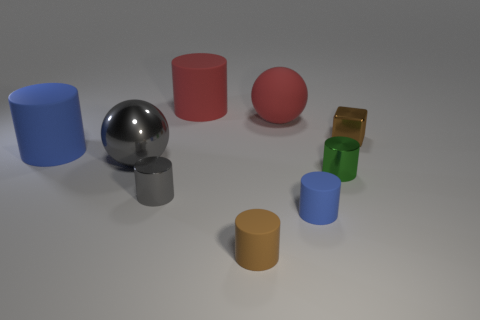There is a tiny cylinder in front of the blue thing that is right of the rubber sphere; what is it made of?
Your response must be concise. Rubber. What shape is the tiny rubber thing that is the same color as the small cube?
Make the answer very short. Cylinder. What shape is the blue rubber thing that is the same size as the metal sphere?
Provide a short and direct response. Cylinder. Are there fewer big red rubber cylinders than red rubber things?
Offer a very short reply. Yes. There is a blue cylinder that is in front of the big gray object; is there a large cylinder in front of it?
Give a very brief answer. No. What shape is the brown thing that is the same material as the big red ball?
Provide a succinct answer. Cylinder. Are there any other things that are the same color as the tiny metal cube?
Provide a short and direct response. Yes. What is the material of the large blue thing that is the same shape as the small green object?
Provide a succinct answer. Rubber. How many other things are the same size as the brown metallic thing?
Offer a terse response. 4. What is the size of the matte object that is the same color as the block?
Offer a very short reply. Small. 